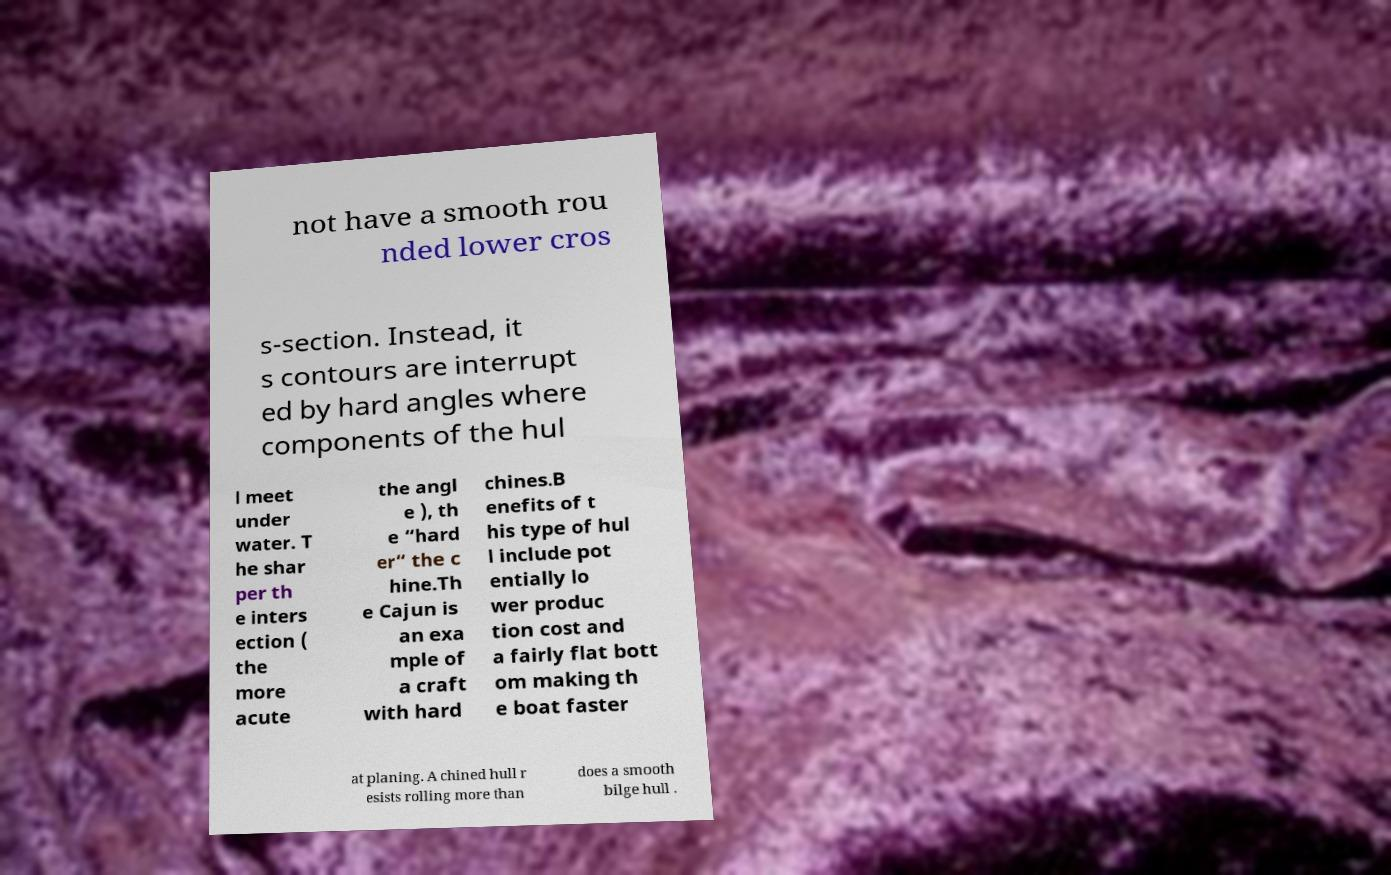There's text embedded in this image that I need extracted. Can you transcribe it verbatim? not have a smooth rou nded lower cros s-section. Instead, it s contours are interrupt ed by hard angles where components of the hul l meet under water. T he shar per th e inters ection ( the more acute the angl e ), th e “hard er“ the c hine.Th e Cajun is an exa mple of a craft with hard chines.B enefits of t his type of hul l include pot entially lo wer produc tion cost and a fairly flat bott om making th e boat faster at planing. A chined hull r esists rolling more than does a smooth bilge hull . 